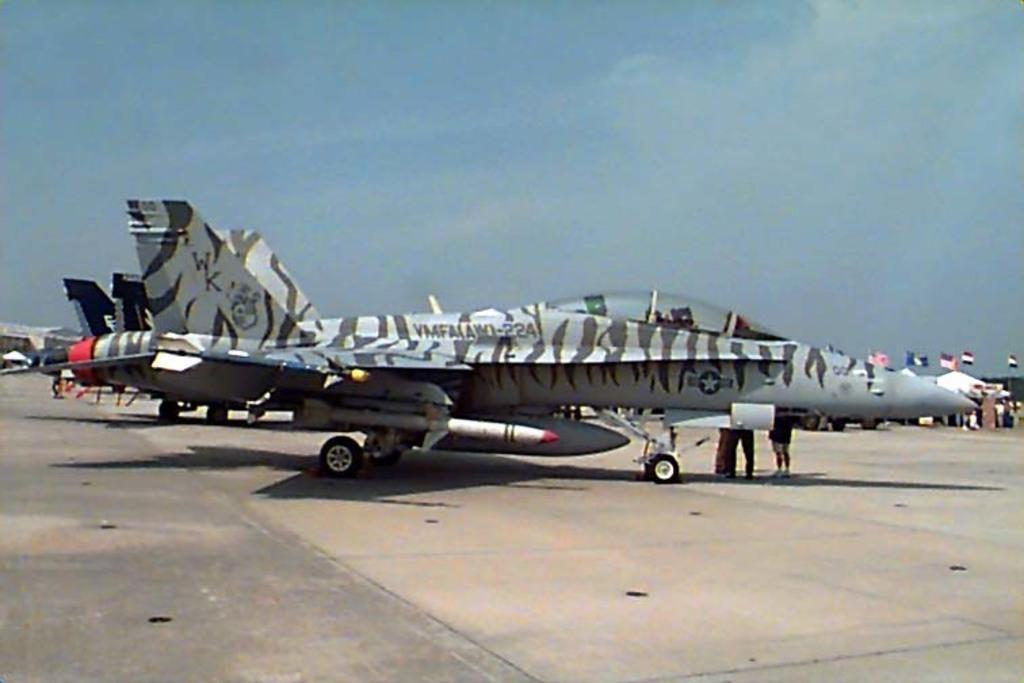How would you summarize this image in a sentence or two? Here we can see airplanes on the road. There are flags and few persons. In the background there is sky. 